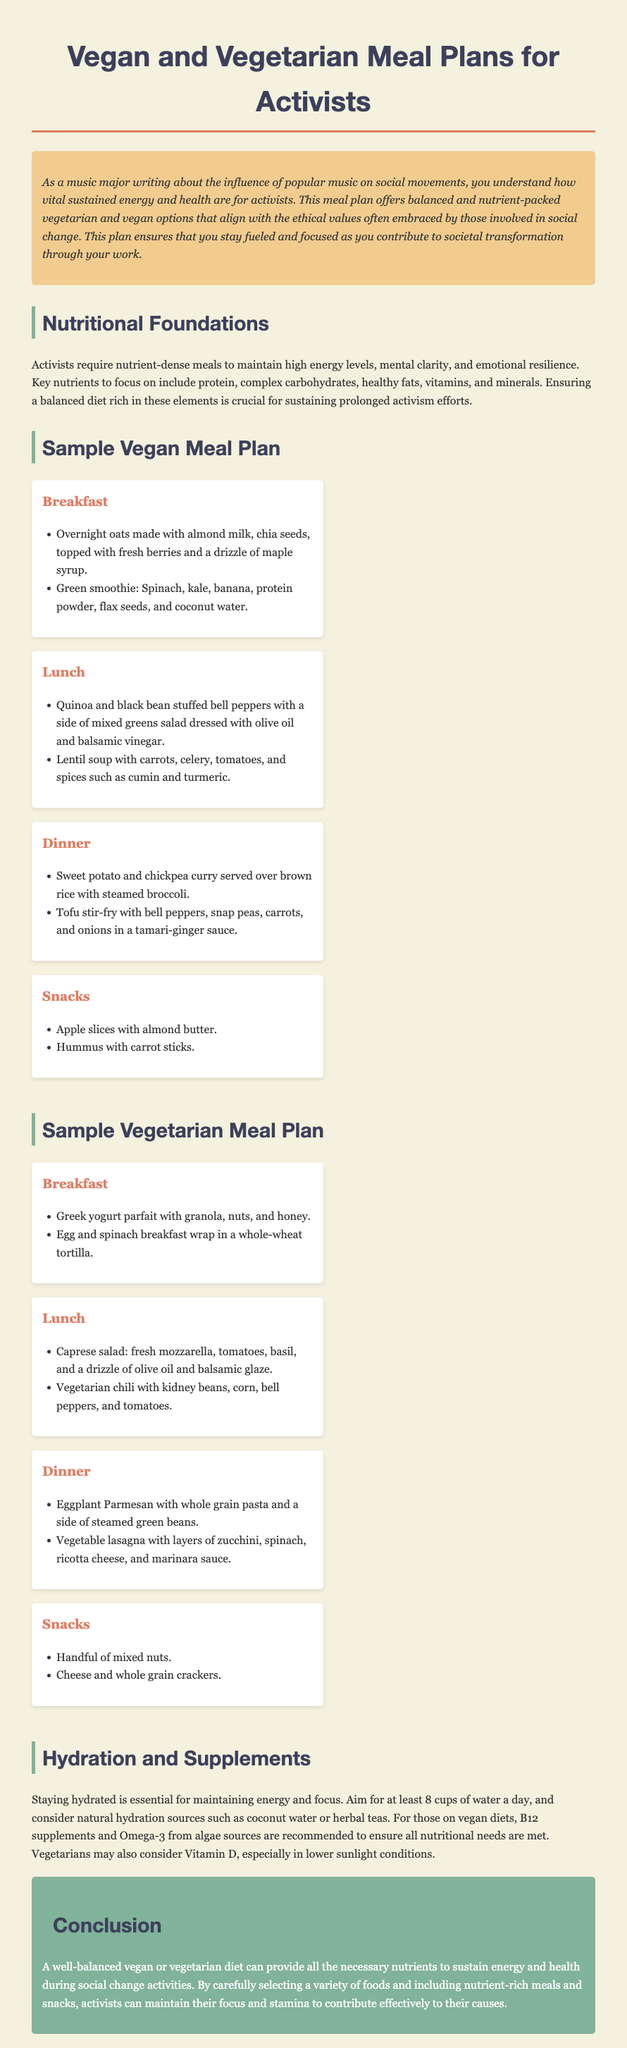What is the title of the document? The title is prominently displayed at the top of the document.
Answer: Vegan and Vegetarian Meal Plans for Activists What type of diet does the sample meal plan promote? The document clearly states the meal plans are for certain dietary preferences.
Answer: Vegan and Vegetarian How many meals are listed in the Vegan Meal Plan? Each section in the Vegan Meal Plan contains a specified number of meals.
Answer: Four What is one ingredient found in the breakfast of the Vegan Meal Plan? The document lists specific food items in the breakfast section.
Answer: Chia seeds What is recommended for hydration in the document? The hydration section specifies recommended liquids for maintaining energy.
Answer: Water What nutrient supplements are suggested for vegans? The document mentions specific supplements for those following a vegan diet.
Answer: B12 Which meal plan includes egg dishes? The document indicates which meal plan is associated with egg consumption.
Answer: Vegetarian Meal Plan What is one example of a snack from the Vegan Meal Plan? The snack section of the Vegan Meal Plan provides specific snack ideas.
Answer: Hummus with carrot sticks What is the purpose of the meal plans outlined in the document? The introduction explains the overall goal of the meal plans for the intended audience.
Answer: Sustaining Energy During Social Change 